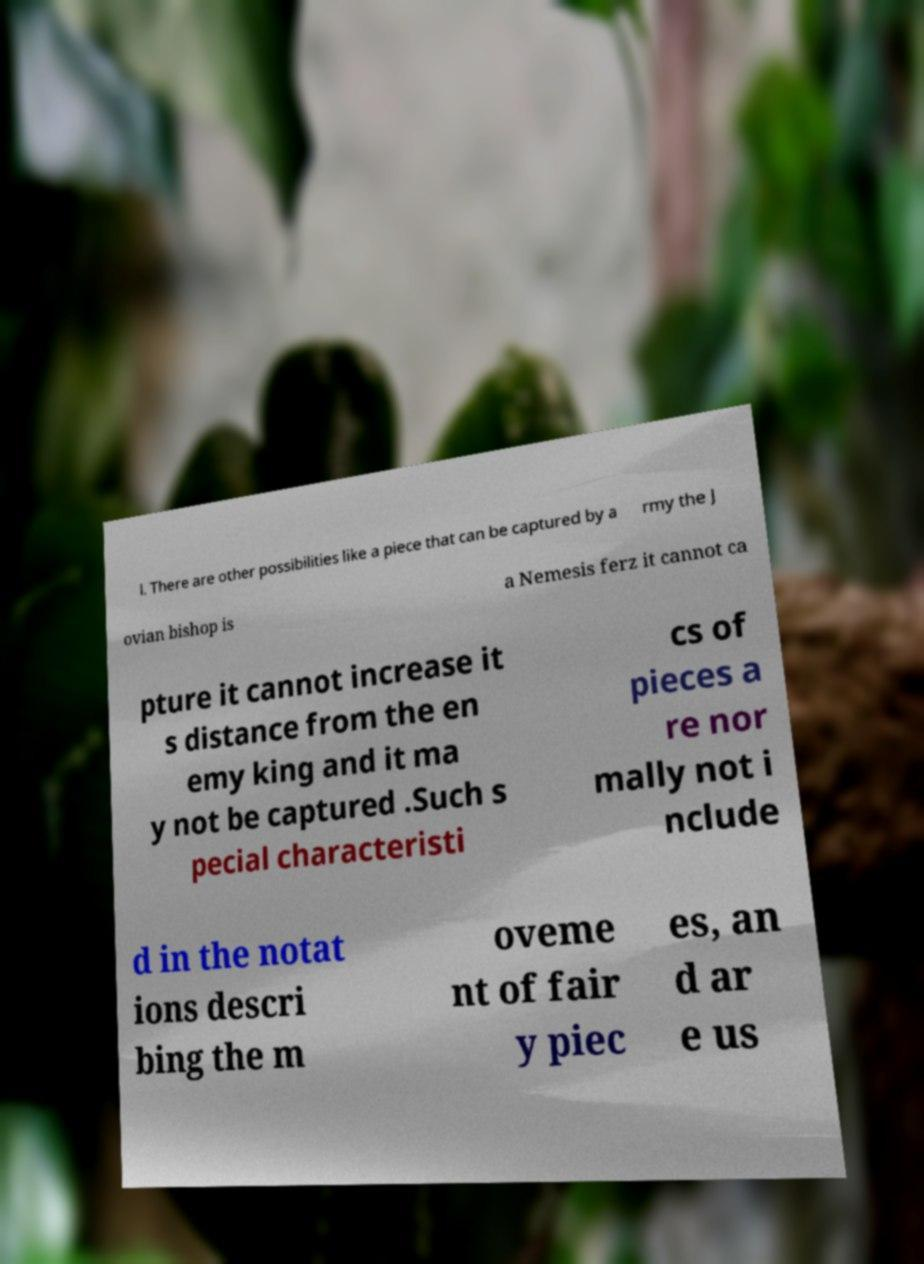For documentation purposes, I need the text within this image transcribed. Could you provide that? l. There are other possibilities like a piece that can be captured by a rmy the J ovian bishop is a Nemesis ferz it cannot ca pture it cannot increase it s distance from the en emy king and it ma y not be captured .Such s pecial characteristi cs of pieces a re nor mally not i nclude d in the notat ions descri bing the m oveme nt of fair y piec es, an d ar e us 